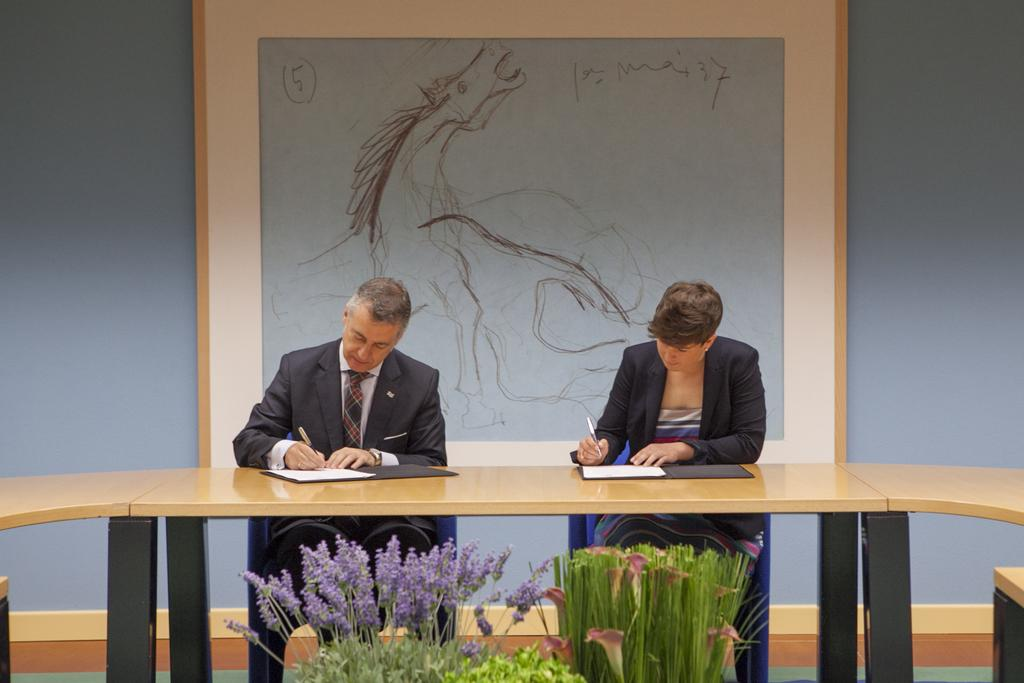Who are the people in the image? There is a man and a woman in the image. What are they doing in the image? They are sitting at a table and writing on a file with a pen. What can be seen in the background of the image? There is a painting in the background. What is present in the front of the table? There are plants in the front of the table. What type of car can be seen in the field behind the plants? There is no car or field present in the image; it features a man and a woman sitting at a table with plants in the front. 